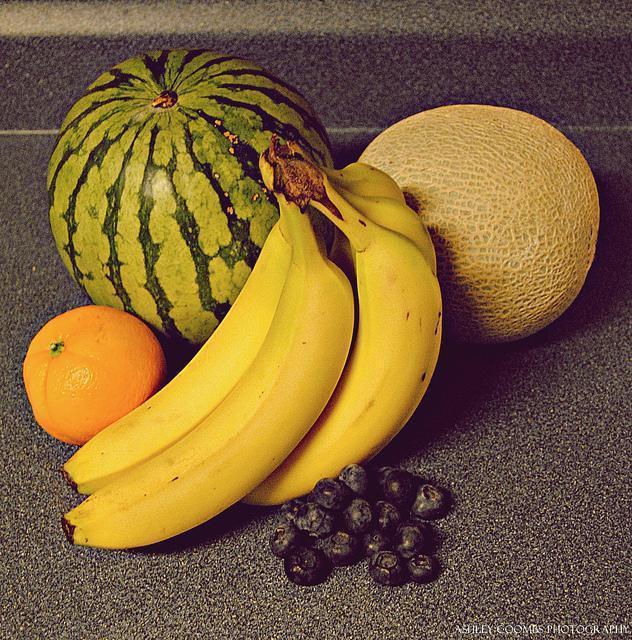Verify the accuracy of this image caption: "The banana is under the orange.".
Answer yes or no. No. 